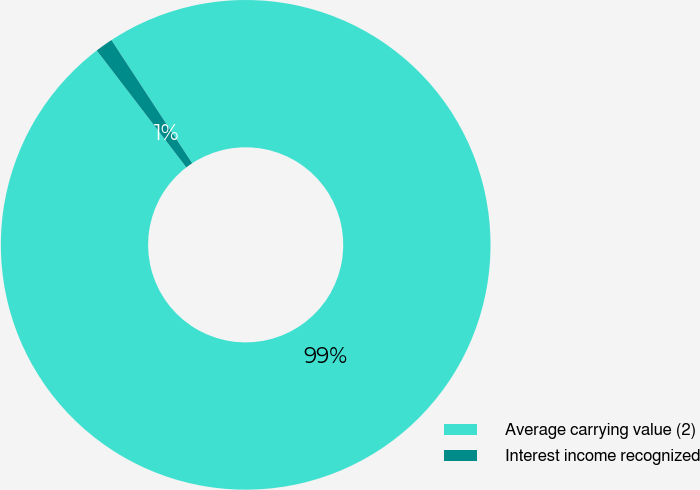<chart> <loc_0><loc_0><loc_500><loc_500><pie_chart><fcel>Average carrying value (2)<fcel>Interest income recognized<nl><fcel>98.83%<fcel>1.17%<nl></chart> 